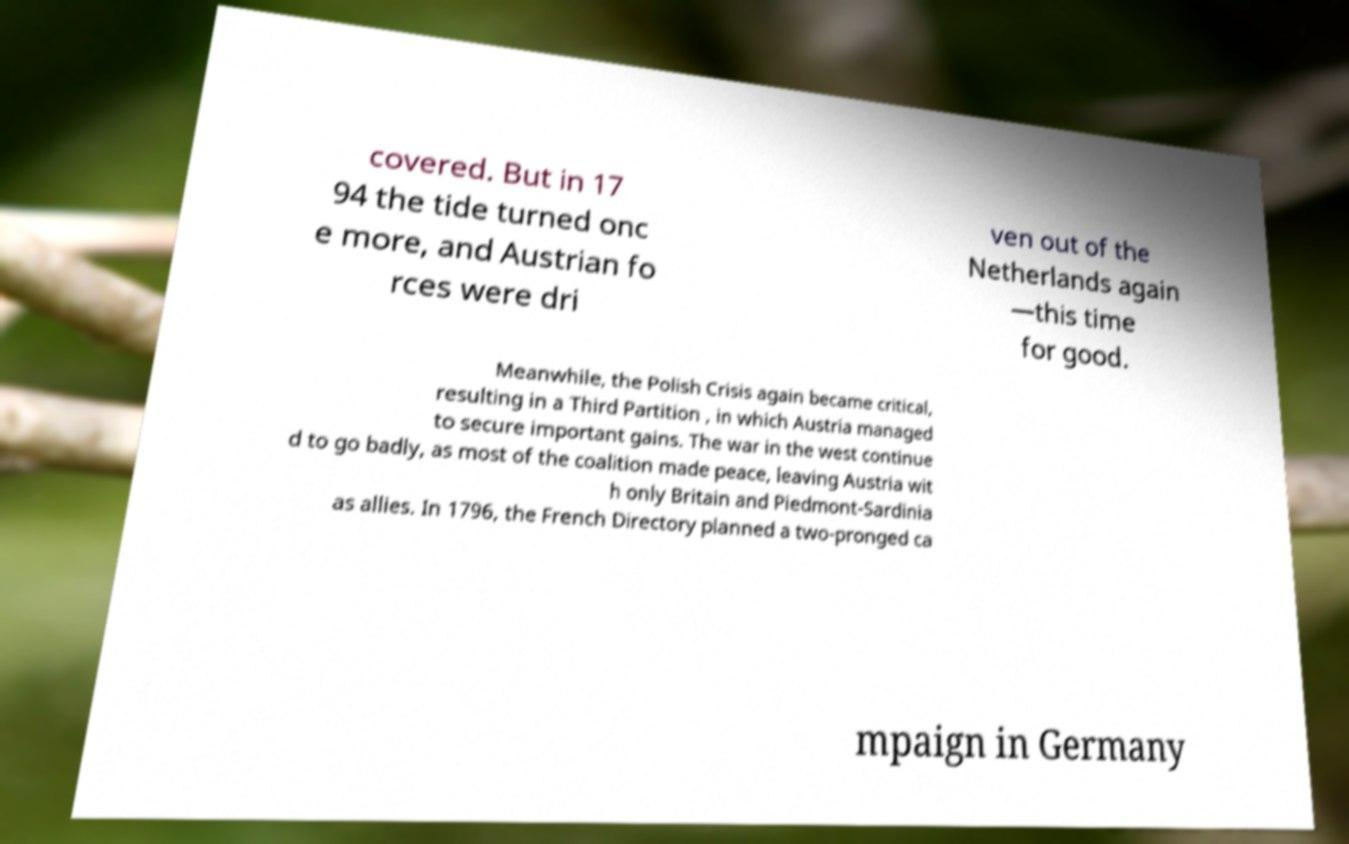Can you accurately transcribe the text from the provided image for me? covered. But in 17 94 the tide turned onc e more, and Austrian fo rces were dri ven out of the Netherlands again —this time for good. Meanwhile, the Polish Crisis again became critical, resulting in a Third Partition , in which Austria managed to secure important gains. The war in the west continue d to go badly, as most of the coalition made peace, leaving Austria wit h only Britain and Piedmont-Sardinia as allies. In 1796, the French Directory planned a two-pronged ca mpaign in Germany 